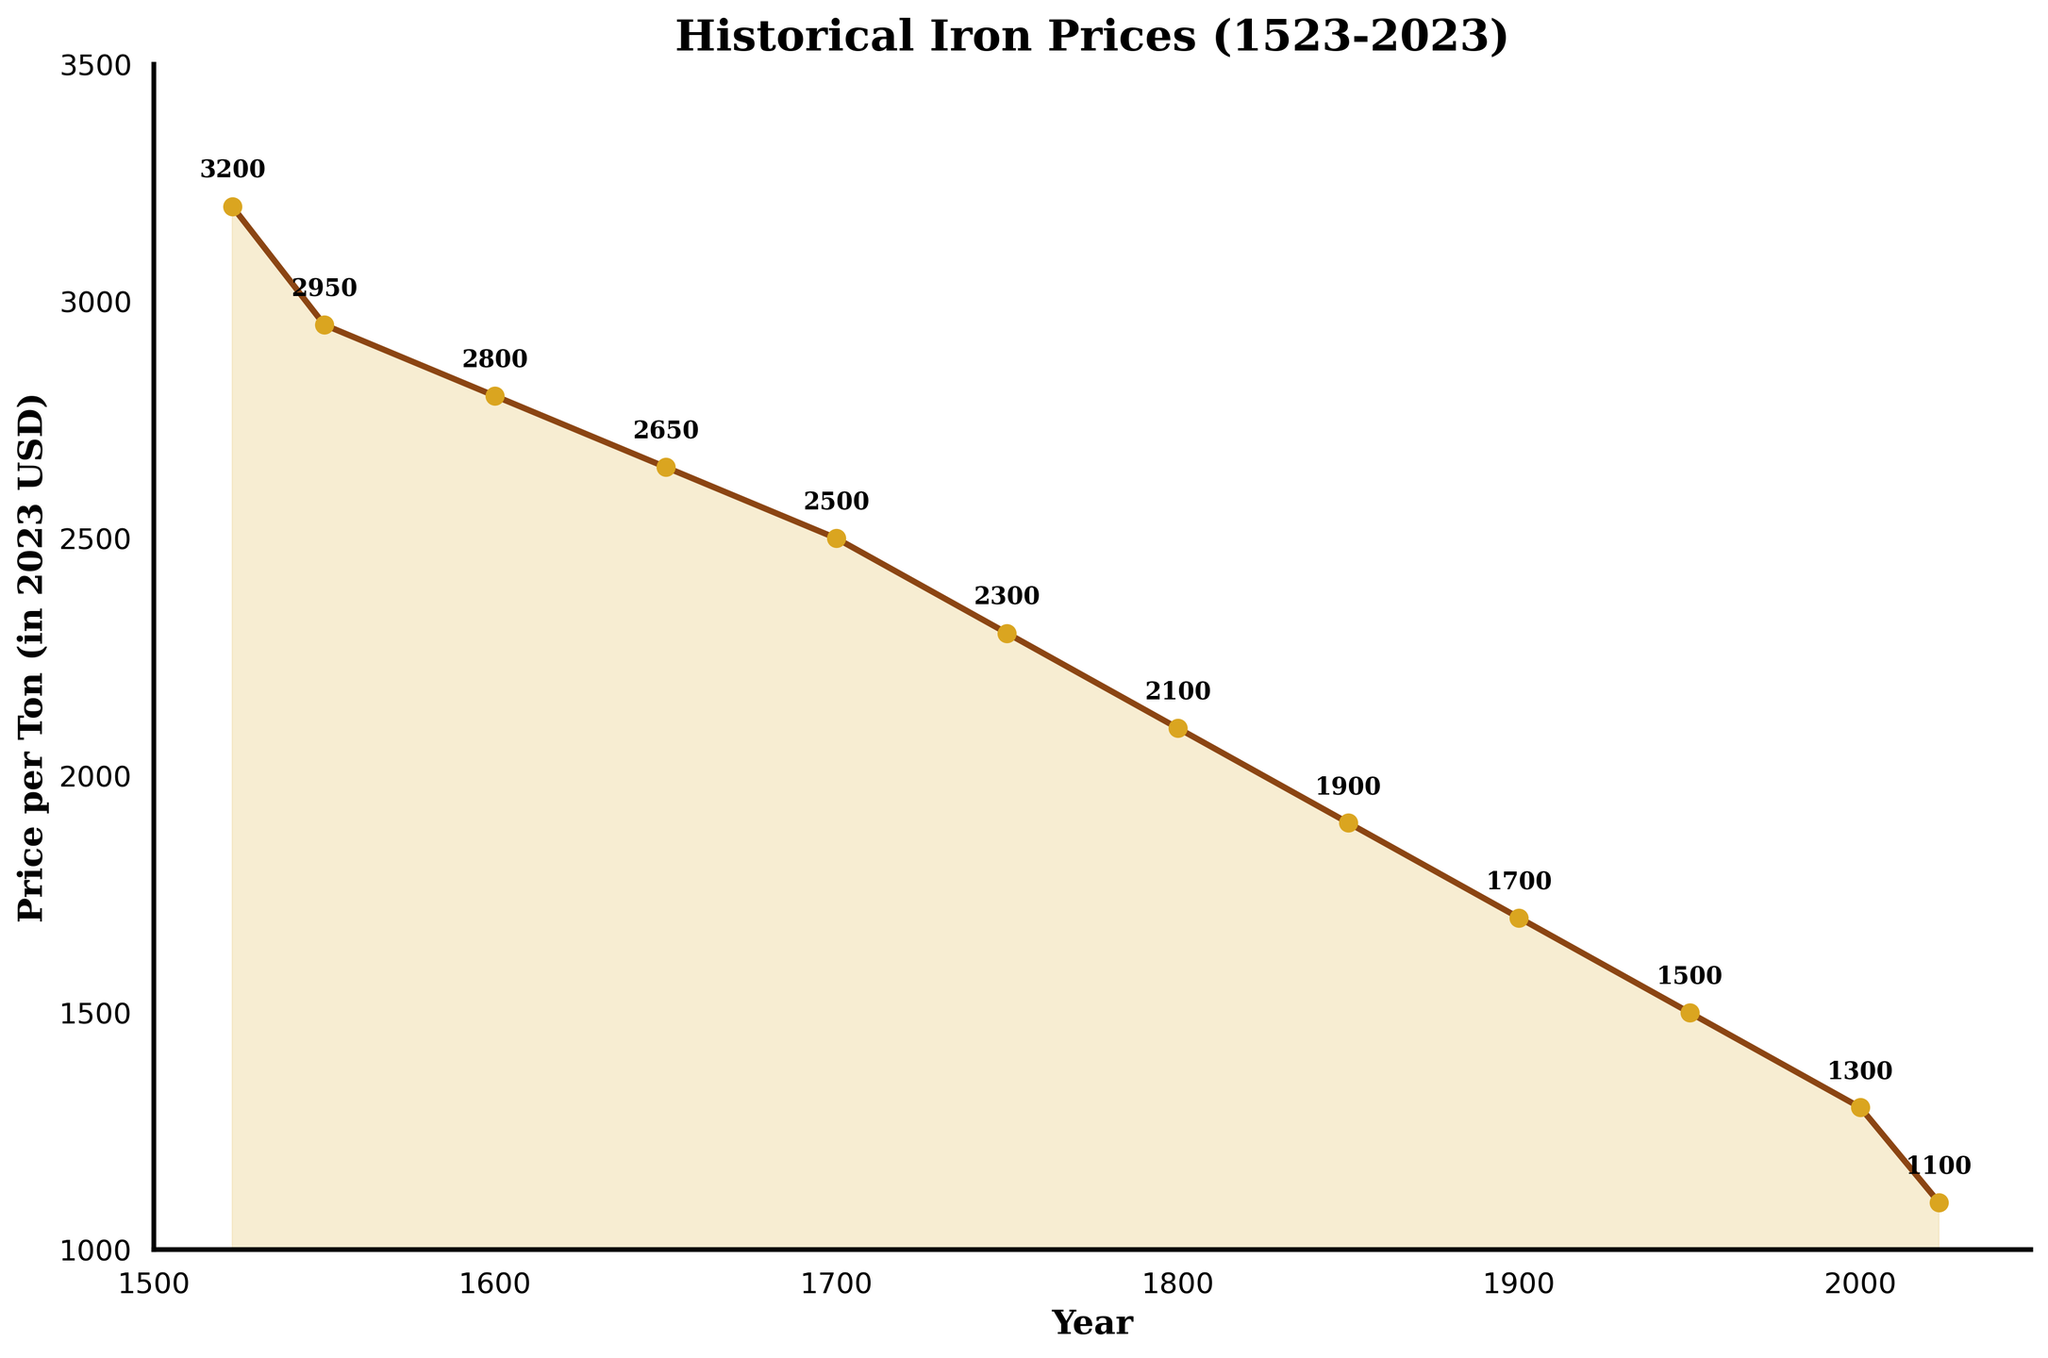What's the price difference between the year 1523 and 2023? To find the price difference, subtract the price in 2023 from the price in 1523: 3200 - 1100 = 2100
Answer: 2100 Between which years does the price of iron decrease the most? Examine the slope between points to find the steepest decline. The largest price drop is between 1523 and 1550, where the price drops from 3200 to 2950, giving a difference of 250. However, the steepest decline overall is between 1800 and 1850 where the price drops from 2100 to 1900, a difference of 200. This is the steepest percentage decline compared to the baseline levels of other drops.
Answer: 1800 to 1850 Which period had a steady decrease in iron prices and what is the average rate of decrease per year during that period? The period from 1523 to 2023 shows a steady decrease in prices from 3200 to 1100. The total timespan is 500 years, and the decrease is 3200 - 1100 = 2100. The average rate of decrease per year is 2100 / 500 = 4.2 USD/year.
Answer: 1523-2023, 4.2 USD/year How many times did the price of iron decrease by more than 100 USD over a span of 50 years? Examine each 50-year period in the data: 1523-1550 (-250), 1550-1600 (-150), 1600-1650 (-150), 1650-1700 (-150), 1700-1750 (-200), 1750-1800 (-200), 1800-1850 (-200), 1850-1900 (-200), 1900-1950 (-200), 1950-2000 (-200), 2000-2023 (-200). Each of these periods shows a decrease of more than 100 USD.
Answer: 11 What's the percentage decrease in the price of iron from 1600 to 1650? Calculate the percentage decrease using the formula: ((Price in 1600 - Price in 1650) / Price in 1600) * 100. That is ((2800 - 2650) / 2800) * 100 ≈ 5.36%.
Answer: 5.36% During which century did the iron price drop most consistently and by how much did it drop? Look at each century and calculate the price drop: 1500s (3200-2950=250), 1600s (2950-2800=150), 1700s (2800-2300=500), 1800s (2300-1700=600), 1900s (1700-1300=400), 2000s till 2023 (1300-1100=200). The 1800s show the most consistent and largest drop of 600 USD.
Answer: 1800s, 600 USD Between 1700 and 2023, which year witnessed the biggest absolute drop in iron prices and what was the drop? By observing the data points, the year with the biggest absolute drop within this span can be seen between 2000 and 2023, where the price dropped from 1300 to 1100, a decrease of 200 USD.
Answer: 2000-2023, 200 USD What is the average iron price over the entire period shown in the chart? Sum all prices and divide by the number of years recorded: (3200 + 2950 + 2800 + 2650 + 2500 + 2300 + 2100 + 1900 + 1700 + 1500 + 1300 + 1100) / 12 = 2183.33 USD.
Answer: 2183.33 USD 